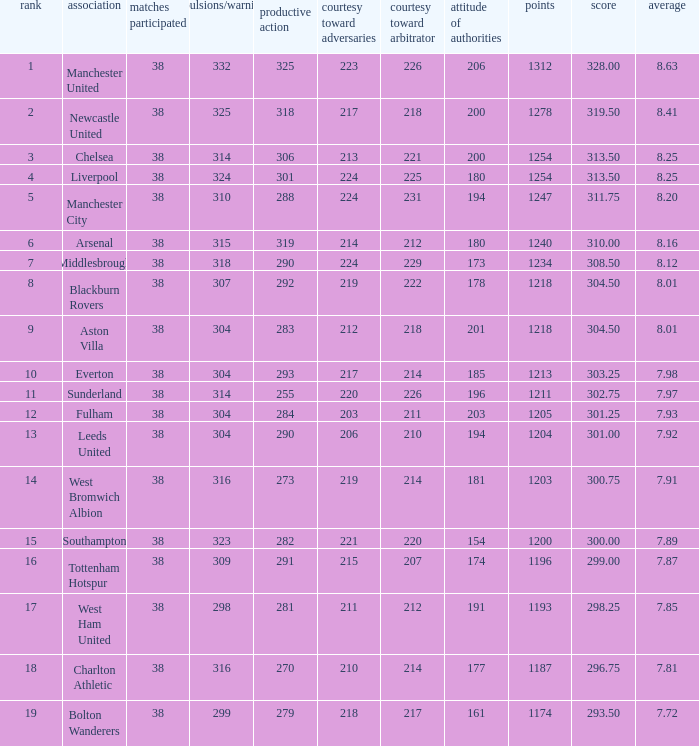Write the full table. {'header': ['rank', 'association', 'matches participated', 'expulsions/warnings', 'productive action', 'courtesy toward adversaries', 'courtesy toward arbitrator', 'attitude of authorities', 'points', 'score', 'average'], 'rows': [['1', 'Manchester United', '38', '332', '325', '223', '226', '206', '1312', '328.00', '8.63'], ['2', 'Newcastle United', '38', '325', '318', '217', '218', '200', '1278', '319.50', '8.41'], ['3', 'Chelsea', '38', '314', '306', '213', '221', '200', '1254', '313.50', '8.25'], ['4', 'Liverpool', '38', '324', '301', '224', '225', '180', '1254', '313.50', '8.25'], ['5', 'Manchester City', '38', '310', '288', '224', '231', '194', '1247', '311.75', '8.20'], ['6', 'Arsenal', '38', '315', '319', '214', '212', '180', '1240', '310.00', '8.16'], ['7', 'Middlesbrough', '38', '318', '290', '224', '229', '173', '1234', '308.50', '8.12'], ['8', 'Blackburn Rovers', '38', '307', '292', '219', '222', '178', '1218', '304.50', '8.01'], ['9', 'Aston Villa', '38', '304', '283', '212', '218', '201', '1218', '304.50', '8.01'], ['10', 'Everton', '38', '304', '293', '217', '214', '185', '1213', '303.25', '7.98'], ['11', 'Sunderland', '38', '314', '255', '220', '226', '196', '1211', '302.75', '7.97'], ['12', 'Fulham', '38', '304', '284', '203', '211', '203', '1205', '301.25', '7.93'], ['13', 'Leeds United', '38', '304', '290', '206', '210', '194', '1204', '301.00', '7.92'], ['14', 'West Bromwich Albion', '38', '316', '273', '219', '214', '181', '1203', '300.75', '7.91'], ['15', 'Southampton', '38', '323', '282', '221', '220', '154', '1200', '300.00', '7.89'], ['16', 'Tottenham Hotspur', '38', '309', '291', '215', '207', '174', '1196', '299.00', '7.87'], ['17', 'West Ham United', '38', '298', '281', '211', '212', '191', '1193', '298.25', '7.85'], ['18', 'Charlton Athletic', '38', '316', '270', '210', '214', '177', '1187', '296.75', '7.81'], ['19', 'Bolton Wanderers', '38', '299', '279', '218', '217', '161', '1174', '293.50', '7.72']]} Name the most pos for west bromwich albion club 14.0. 